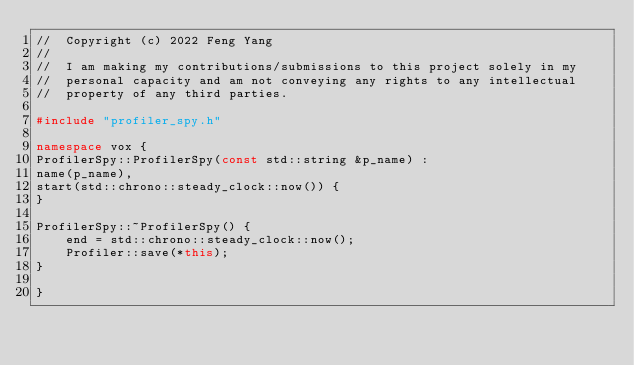Convert code to text. <code><loc_0><loc_0><loc_500><loc_500><_C++_>//  Copyright (c) 2022 Feng Yang
//
//  I am making my contributions/submissions to this project solely in my
//  personal capacity and am not conveying any rights to any intellectual
//  property of any third parties.

#include "profiler_spy.h"

namespace vox {
ProfilerSpy::ProfilerSpy(const std::string &p_name) :
name(p_name),
start(std::chrono::steady_clock::now()) {
}

ProfilerSpy::~ProfilerSpy() {
    end = std::chrono::steady_clock::now();
    Profiler::save(*this);
}

}
</code> 